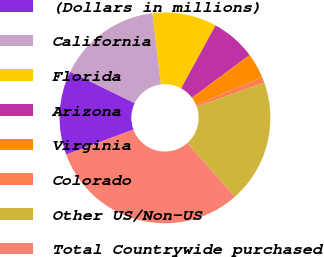Convert chart to OTSL. <chart><loc_0><loc_0><loc_500><loc_500><pie_chart><fcel>(Dollars in millions)<fcel>California<fcel>Florida<fcel>Arizona<fcel>Virginia<fcel>Colorado<fcel>Other US/Non-US<fcel>Total Countrywide purchased<nl><fcel>12.88%<fcel>15.88%<fcel>9.87%<fcel>6.87%<fcel>3.87%<fcel>0.87%<fcel>18.88%<fcel>30.88%<nl></chart> 